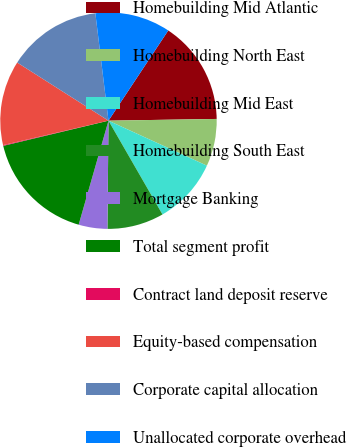Convert chart. <chart><loc_0><loc_0><loc_500><loc_500><pie_chart><fcel>Homebuilding Mid Atlantic<fcel>Homebuilding North East<fcel>Homebuilding Mid East<fcel>Homebuilding South East<fcel>Mortgage Banking<fcel>Total segment profit<fcel>Contract land deposit reserve<fcel>Equity-based compensation<fcel>Corporate capital allocation<fcel>Unallocated corporate overhead<nl><fcel>15.43%<fcel>7.08%<fcel>9.86%<fcel>8.47%<fcel>4.29%<fcel>16.82%<fcel>0.11%<fcel>12.65%<fcel>14.04%<fcel>11.25%<nl></chart> 